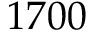Convert formula to latex. <formula><loc_0><loc_0><loc_500><loc_500>1 7 0 0</formula> 